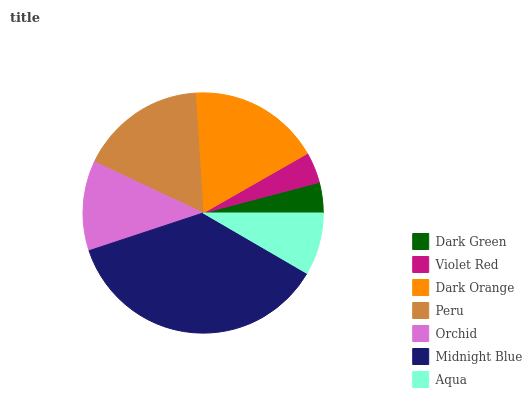Is Dark Green the minimum?
Answer yes or no. Yes. Is Midnight Blue the maximum?
Answer yes or no. Yes. Is Violet Red the minimum?
Answer yes or no. No. Is Violet Red the maximum?
Answer yes or no. No. Is Violet Red greater than Dark Green?
Answer yes or no. Yes. Is Dark Green less than Violet Red?
Answer yes or no. Yes. Is Dark Green greater than Violet Red?
Answer yes or no. No. Is Violet Red less than Dark Green?
Answer yes or no. No. Is Orchid the high median?
Answer yes or no. Yes. Is Orchid the low median?
Answer yes or no. Yes. Is Midnight Blue the high median?
Answer yes or no. No. Is Aqua the low median?
Answer yes or no. No. 